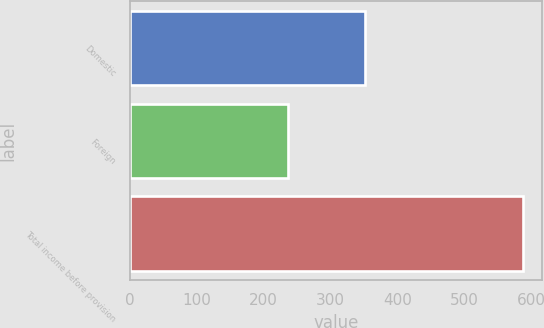<chart> <loc_0><loc_0><loc_500><loc_500><bar_chart><fcel>Domestic<fcel>Foreign<fcel>Total income before provision<nl><fcel>351.1<fcel>236.4<fcel>587.5<nl></chart> 